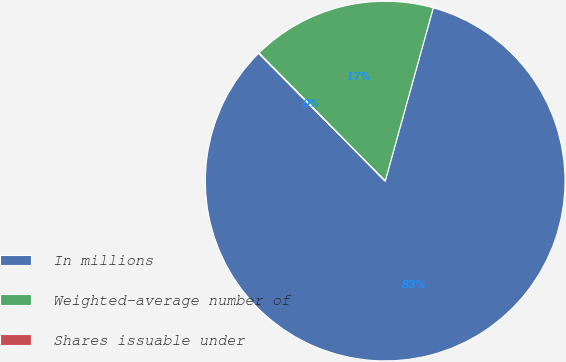Convert chart. <chart><loc_0><loc_0><loc_500><loc_500><pie_chart><fcel>In millions<fcel>Weighted-average number of<fcel>Shares issuable under<nl><fcel>83.27%<fcel>16.69%<fcel>0.04%<nl></chart> 